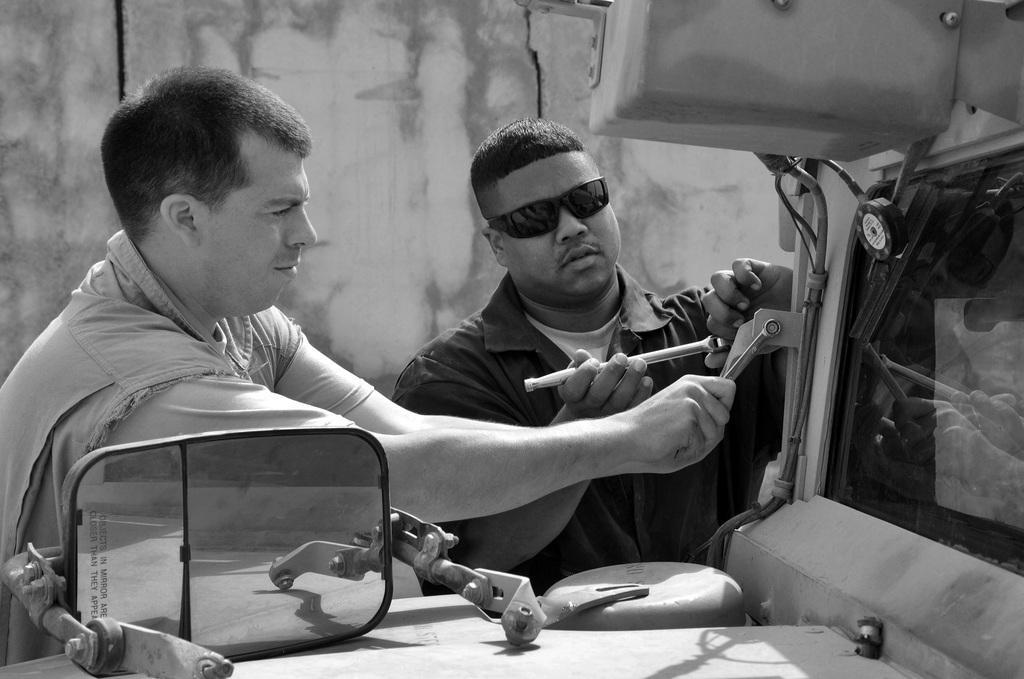How would you summarize this image in a sentence or two? In this black and white image there are two persons repairing a vehicle and on the bonnet there is a mirror of a vehicle. In the background there is a wall. 